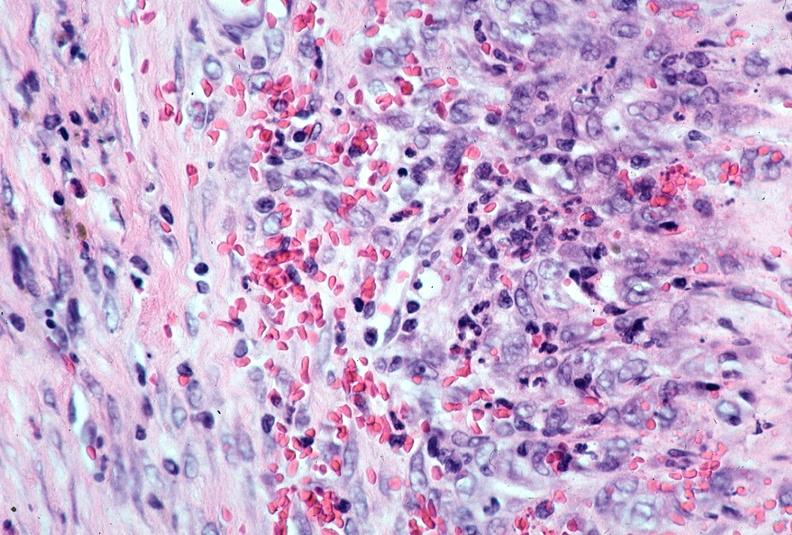what does this image show?
Answer the question using a single word or phrase. Vasculitis 